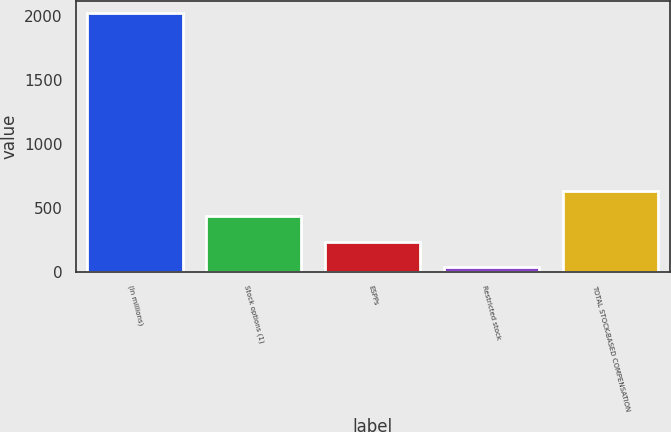<chart> <loc_0><loc_0><loc_500><loc_500><bar_chart><fcel>(In millions)<fcel>Stock options (1)<fcel>ESPPs<fcel>Restricted stock<fcel>TOTAL STOCK-BASED COMPENSATION<nl><fcel>2017<fcel>430.6<fcel>232.3<fcel>34<fcel>628.9<nl></chart> 